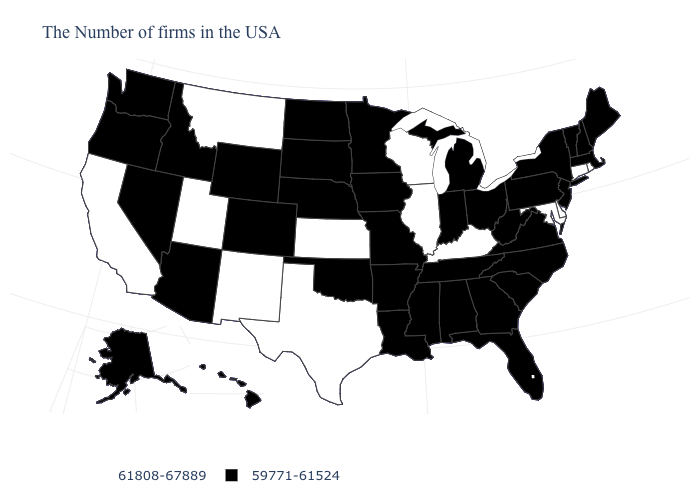What is the value of Rhode Island?
Give a very brief answer. 61808-67889. Among the states that border Massachusetts , does Rhode Island have the highest value?
Keep it brief. Yes. Name the states that have a value in the range 59771-61524?
Concise answer only. Maine, Massachusetts, New Hampshire, Vermont, New York, New Jersey, Pennsylvania, Virginia, North Carolina, South Carolina, West Virginia, Ohio, Florida, Georgia, Michigan, Indiana, Alabama, Tennessee, Mississippi, Louisiana, Missouri, Arkansas, Minnesota, Iowa, Nebraska, Oklahoma, South Dakota, North Dakota, Wyoming, Colorado, Arizona, Idaho, Nevada, Washington, Oregon, Alaska, Hawaii. What is the lowest value in the Northeast?
Write a very short answer. 59771-61524. What is the value of Maryland?
Quick response, please. 61808-67889. Does Delaware have the lowest value in the South?
Be succinct. No. Does Iowa have the same value as Idaho?
Answer briefly. Yes. Name the states that have a value in the range 59771-61524?
Give a very brief answer. Maine, Massachusetts, New Hampshire, Vermont, New York, New Jersey, Pennsylvania, Virginia, North Carolina, South Carolina, West Virginia, Ohio, Florida, Georgia, Michigan, Indiana, Alabama, Tennessee, Mississippi, Louisiana, Missouri, Arkansas, Minnesota, Iowa, Nebraska, Oklahoma, South Dakota, North Dakota, Wyoming, Colorado, Arizona, Idaho, Nevada, Washington, Oregon, Alaska, Hawaii. Name the states that have a value in the range 59771-61524?
Write a very short answer. Maine, Massachusetts, New Hampshire, Vermont, New York, New Jersey, Pennsylvania, Virginia, North Carolina, South Carolina, West Virginia, Ohio, Florida, Georgia, Michigan, Indiana, Alabama, Tennessee, Mississippi, Louisiana, Missouri, Arkansas, Minnesota, Iowa, Nebraska, Oklahoma, South Dakota, North Dakota, Wyoming, Colorado, Arizona, Idaho, Nevada, Washington, Oregon, Alaska, Hawaii. What is the highest value in states that border Nebraska?
Give a very brief answer. 61808-67889. Name the states that have a value in the range 59771-61524?
Give a very brief answer. Maine, Massachusetts, New Hampshire, Vermont, New York, New Jersey, Pennsylvania, Virginia, North Carolina, South Carolina, West Virginia, Ohio, Florida, Georgia, Michigan, Indiana, Alabama, Tennessee, Mississippi, Louisiana, Missouri, Arkansas, Minnesota, Iowa, Nebraska, Oklahoma, South Dakota, North Dakota, Wyoming, Colorado, Arizona, Idaho, Nevada, Washington, Oregon, Alaska, Hawaii. Name the states that have a value in the range 59771-61524?
Write a very short answer. Maine, Massachusetts, New Hampshire, Vermont, New York, New Jersey, Pennsylvania, Virginia, North Carolina, South Carolina, West Virginia, Ohio, Florida, Georgia, Michigan, Indiana, Alabama, Tennessee, Mississippi, Louisiana, Missouri, Arkansas, Minnesota, Iowa, Nebraska, Oklahoma, South Dakota, North Dakota, Wyoming, Colorado, Arizona, Idaho, Nevada, Washington, Oregon, Alaska, Hawaii. Does Texas have the lowest value in the USA?
Give a very brief answer. No. Name the states that have a value in the range 61808-67889?
Be succinct. Rhode Island, Connecticut, Delaware, Maryland, Kentucky, Wisconsin, Illinois, Kansas, Texas, New Mexico, Utah, Montana, California. Name the states that have a value in the range 61808-67889?
Answer briefly. Rhode Island, Connecticut, Delaware, Maryland, Kentucky, Wisconsin, Illinois, Kansas, Texas, New Mexico, Utah, Montana, California. 